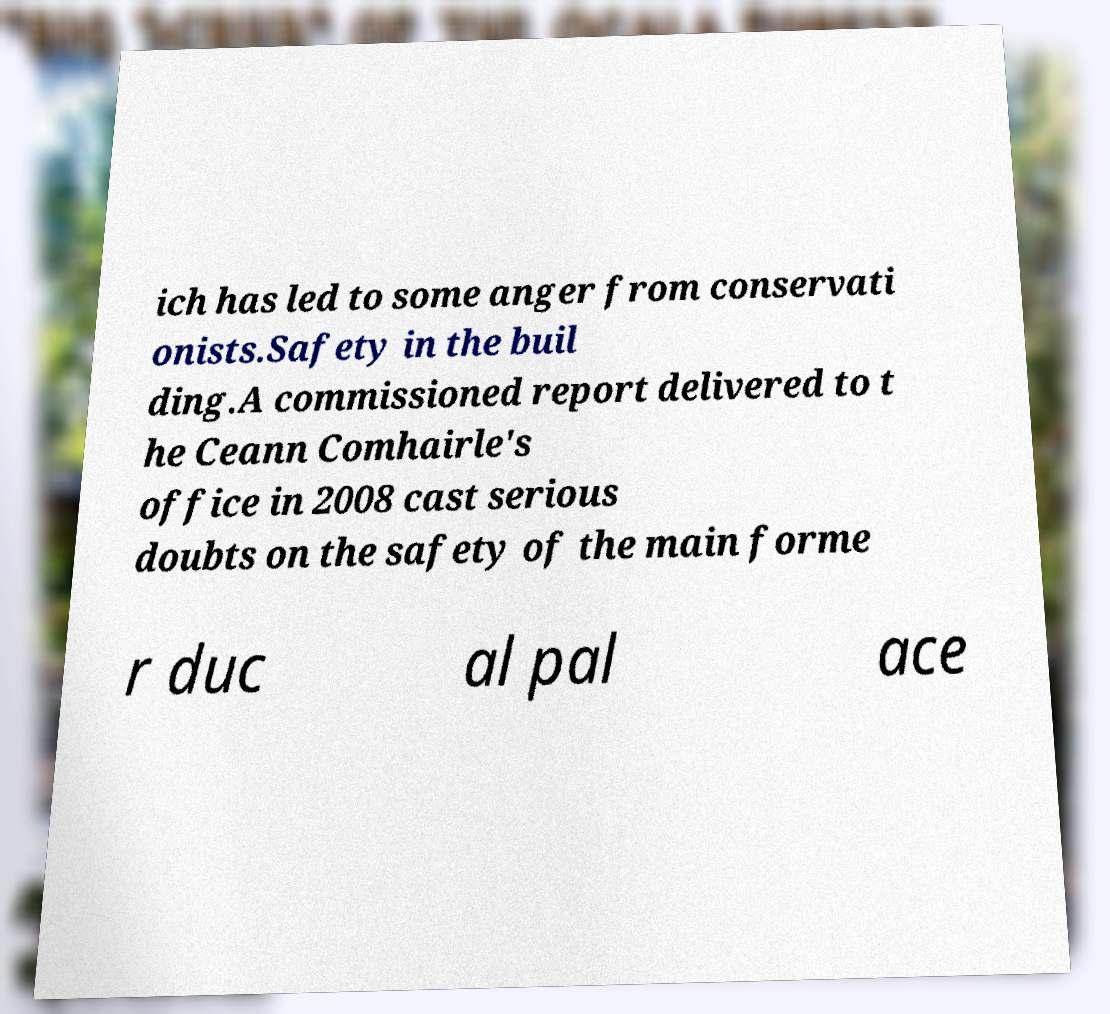Can you read and provide the text displayed in the image?This photo seems to have some interesting text. Can you extract and type it out for me? ich has led to some anger from conservati onists.Safety in the buil ding.A commissioned report delivered to t he Ceann Comhairle's office in 2008 cast serious doubts on the safety of the main forme r duc al pal ace 